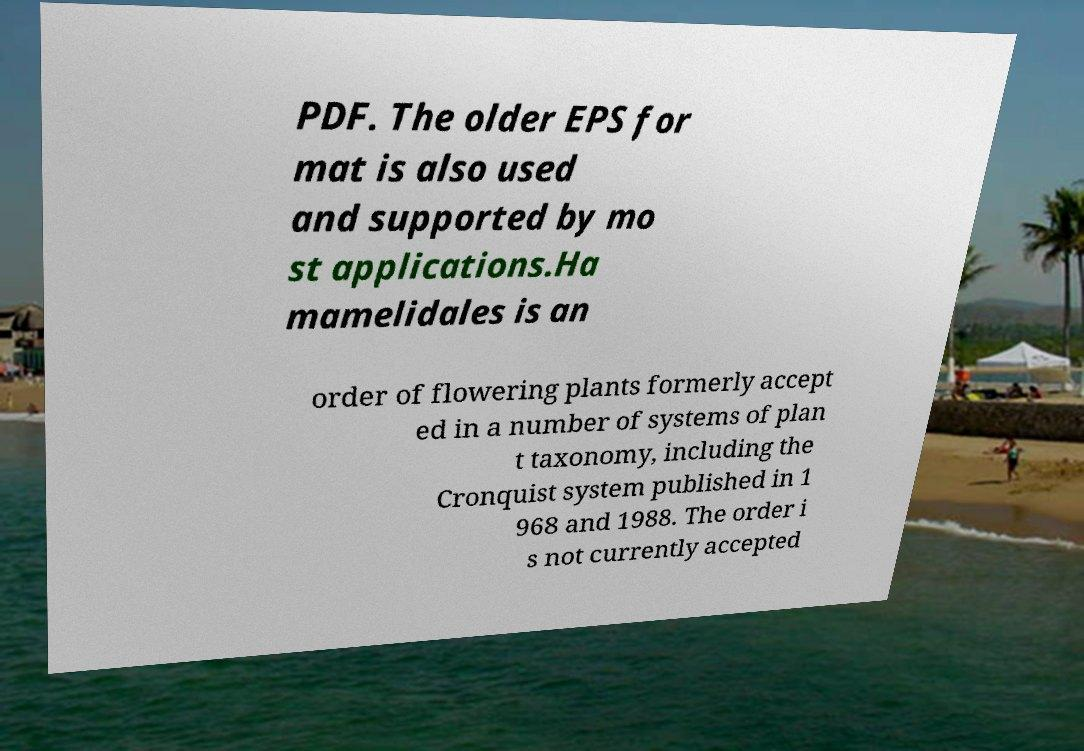For documentation purposes, I need the text within this image transcribed. Could you provide that? PDF. The older EPS for mat is also used and supported by mo st applications.Ha mamelidales is an order of flowering plants formerly accept ed in a number of systems of plan t taxonomy, including the Cronquist system published in 1 968 and 1988. The order i s not currently accepted 